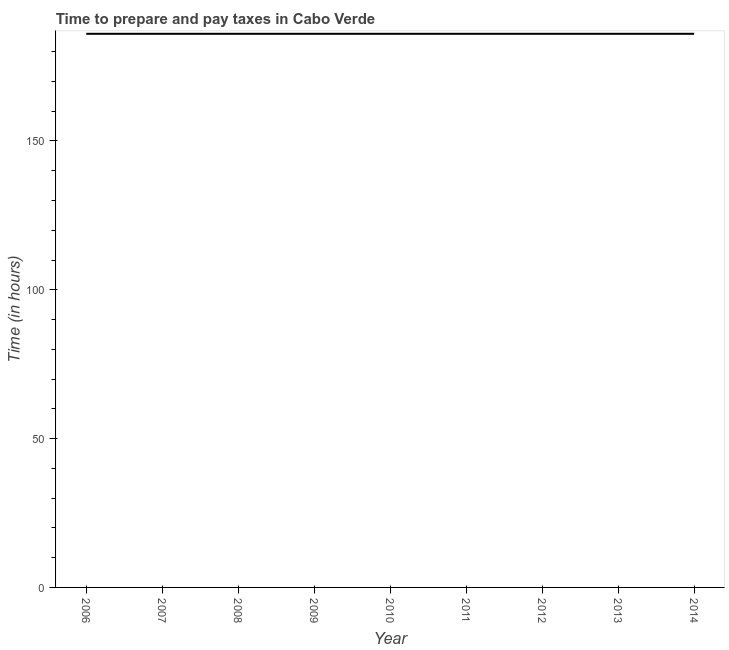What is the time to prepare and pay taxes in 2010?
Ensure brevity in your answer.  186. Across all years, what is the maximum time to prepare and pay taxes?
Your answer should be compact. 186. Across all years, what is the minimum time to prepare and pay taxes?
Make the answer very short. 186. In which year was the time to prepare and pay taxes maximum?
Your answer should be very brief. 2006. What is the sum of the time to prepare and pay taxes?
Provide a short and direct response. 1674. What is the average time to prepare and pay taxes per year?
Your answer should be compact. 186. What is the median time to prepare and pay taxes?
Give a very brief answer. 186. Is the difference between the time to prepare and pay taxes in 2006 and 2011 greater than the difference between any two years?
Your response must be concise. Yes. What is the difference between the highest and the second highest time to prepare and pay taxes?
Ensure brevity in your answer.  0. Is the sum of the time to prepare and pay taxes in 2006 and 2007 greater than the maximum time to prepare and pay taxes across all years?
Your response must be concise. Yes. What is the difference between the highest and the lowest time to prepare and pay taxes?
Provide a short and direct response. 0. In how many years, is the time to prepare and pay taxes greater than the average time to prepare and pay taxes taken over all years?
Provide a short and direct response. 0. Does the time to prepare and pay taxes monotonically increase over the years?
Make the answer very short. No. How many years are there in the graph?
Offer a very short reply. 9. Are the values on the major ticks of Y-axis written in scientific E-notation?
Make the answer very short. No. Does the graph contain any zero values?
Give a very brief answer. No. What is the title of the graph?
Your answer should be compact. Time to prepare and pay taxes in Cabo Verde. What is the label or title of the Y-axis?
Offer a very short reply. Time (in hours). What is the Time (in hours) of 2006?
Your response must be concise. 186. What is the Time (in hours) in 2007?
Give a very brief answer. 186. What is the Time (in hours) of 2008?
Your answer should be compact. 186. What is the Time (in hours) of 2009?
Keep it short and to the point. 186. What is the Time (in hours) of 2010?
Provide a short and direct response. 186. What is the Time (in hours) in 2011?
Your answer should be very brief. 186. What is the Time (in hours) in 2012?
Keep it short and to the point. 186. What is the Time (in hours) in 2013?
Provide a short and direct response. 186. What is the Time (in hours) in 2014?
Give a very brief answer. 186. What is the difference between the Time (in hours) in 2006 and 2007?
Provide a succinct answer. 0. What is the difference between the Time (in hours) in 2006 and 2009?
Your answer should be very brief. 0. What is the difference between the Time (in hours) in 2006 and 2010?
Ensure brevity in your answer.  0. What is the difference between the Time (in hours) in 2006 and 2011?
Your answer should be compact. 0. What is the difference between the Time (in hours) in 2006 and 2014?
Ensure brevity in your answer.  0. What is the difference between the Time (in hours) in 2007 and 2008?
Make the answer very short. 0. What is the difference between the Time (in hours) in 2007 and 2009?
Provide a short and direct response. 0. What is the difference between the Time (in hours) in 2007 and 2010?
Provide a short and direct response. 0. What is the difference between the Time (in hours) in 2007 and 2011?
Make the answer very short. 0. What is the difference between the Time (in hours) in 2007 and 2013?
Offer a very short reply. 0. What is the difference between the Time (in hours) in 2008 and 2012?
Your answer should be very brief. 0. What is the difference between the Time (in hours) in 2008 and 2013?
Your answer should be very brief. 0. What is the difference between the Time (in hours) in 2008 and 2014?
Your answer should be very brief. 0. What is the difference between the Time (in hours) in 2009 and 2011?
Your answer should be very brief. 0. What is the difference between the Time (in hours) in 2009 and 2012?
Your answer should be compact. 0. What is the difference between the Time (in hours) in 2010 and 2011?
Offer a terse response. 0. What is the difference between the Time (in hours) in 2010 and 2012?
Keep it short and to the point. 0. What is the difference between the Time (in hours) in 2010 and 2013?
Keep it short and to the point. 0. What is the difference between the Time (in hours) in 2012 and 2014?
Your answer should be very brief. 0. What is the difference between the Time (in hours) in 2013 and 2014?
Your answer should be very brief. 0. What is the ratio of the Time (in hours) in 2006 to that in 2008?
Provide a short and direct response. 1. What is the ratio of the Time (in hours) in 2006 to that in 2009?
Your response must be concise. 1. What is the ratio of the Time (in hours) in 2006 to that in 2010?
Offer a terse response. 1. What is the ratio of the Time (in hours) in 2006 to that in 2011?
Keep it short and to the point. 1. What is the ratio of the Time (in hours) in 2006 to that in 2012?
Offer a very short reply. 1. What is the ratio of the Time (in hours) in 2007 to that in 2010?
Provide a succinct answer. 1. What is the ratio of the Time (in hours) in 2007 to that in 2014?
Your answer should be compact. 1. What is the ratio of the Time (in hours) in 2008 to that in 2011?
Your response must be concise. 1. What is the ratio of the Time (in hours) in 2008 to that in 2013?
Ensure brevity in your answer.  1. What is the ratio of the Time (in hours) in 2010 to that in 2012?
Your answer should be very brief. 1. What is the ratio of the Time (in hours) in 2010 to that in 2013?
Offer a very short reply. 1. What is the ratio of the Time (in hours) in 2011 to that in 2012?
Your response must be concise. 1. What is the ratio of the Time (in hours) in 2011 to that in 2013?
Ensure brevity in your answer.  1. What is the ratio of the Time (in hours) in 2012 to that in 2013?
Offer a very short reply. 1. What is the ratio of the Time (in hours) in 2012 to that in 2014?
Make the answer very short. 1. 